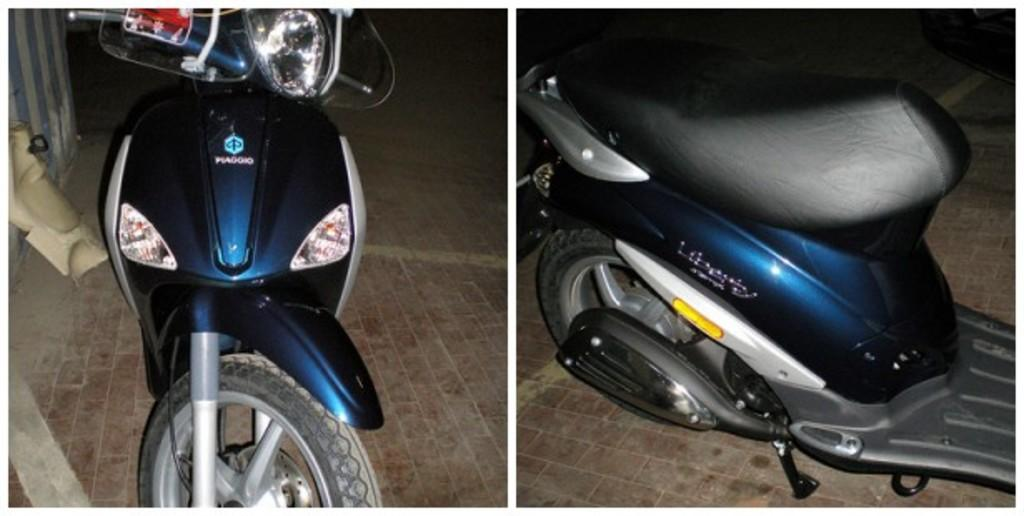What is the composition of the image? The image is a collage of two pictures. What is the common subject in both pictures? Both pictures contain scooters. What can be seen on the left side of the image? There is a wall on the left side of the image. What type of coat is the scooter wearing in the image? There are no coats present in the image, as scooters are inanimate objects and do not wear clothing. 